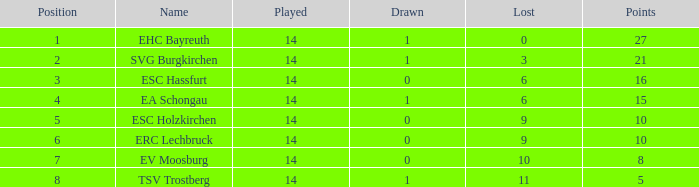What's the lost when there were more than 16 points and had a drawn less than 1? None. 